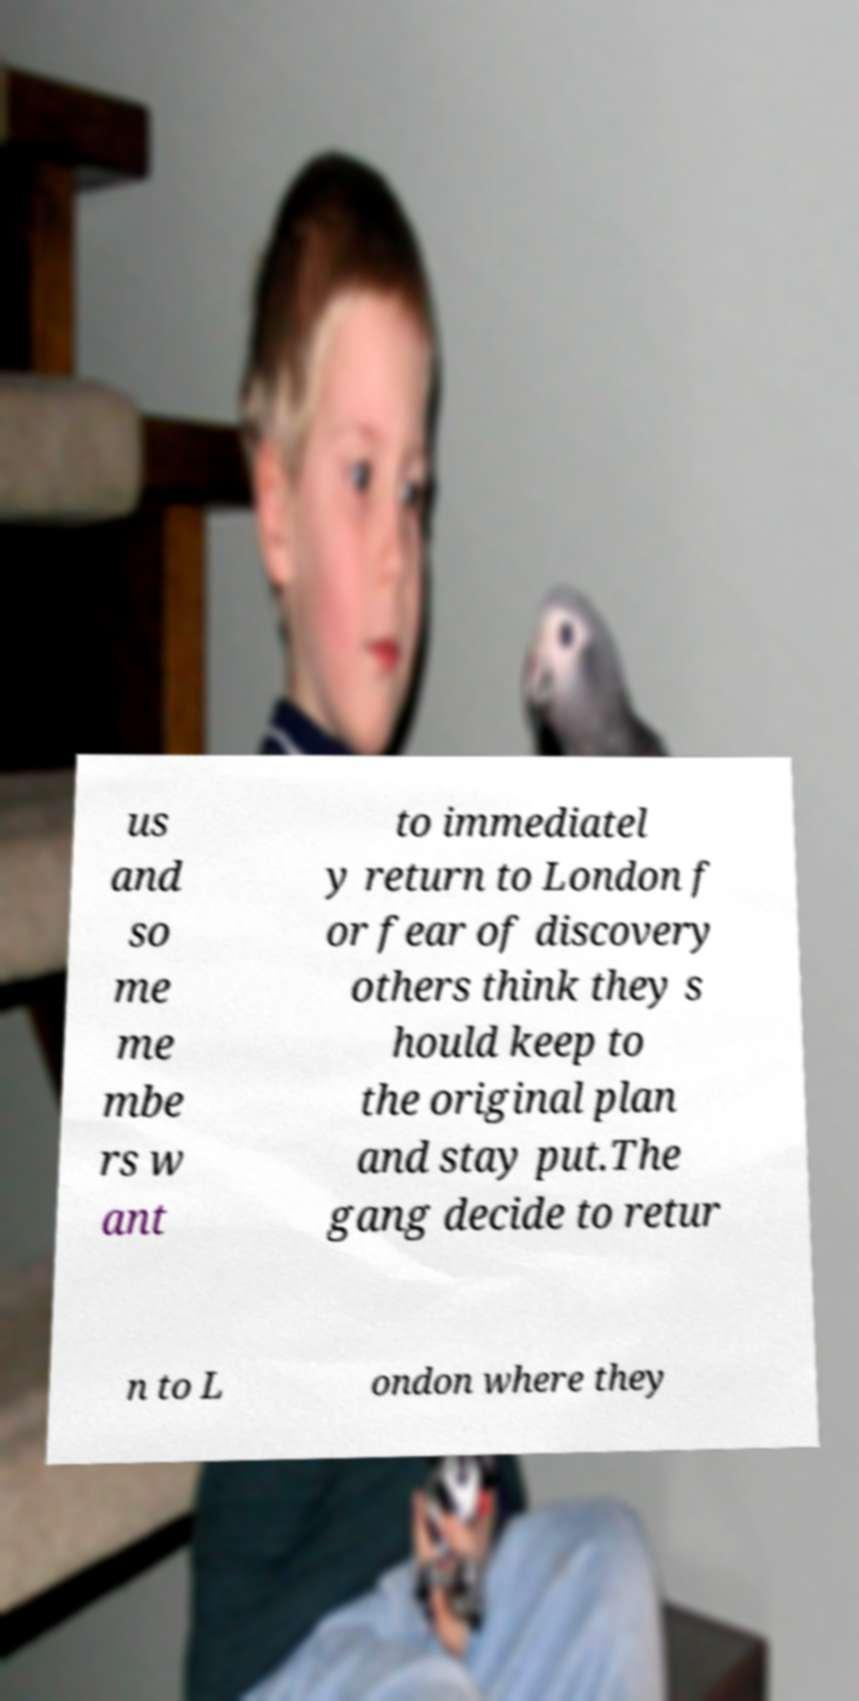Can you accurately transcribe the text from the provided image for me? us and so me me mbe rs w ant to immediatel y return to London f or fear of discovery others think they s hould keep to the original plan and stay put.The gang decide to retur n to L ondon where they 